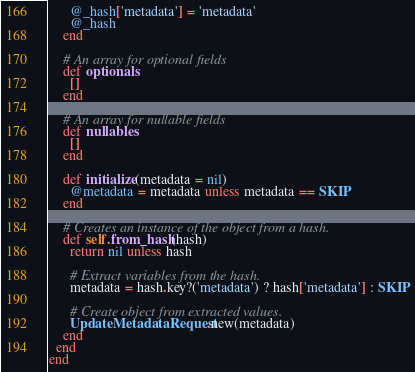Convert code to text. <code><loc_0><loc_0><loc_500><loc_500><_Ruby_>      @_hash['metadata'] = 'metadata'
      @_hash
    end

    # An array for optional fields
    def optionals
      []
    end

    # An array for nullable fields
    def nullables
      []
    end

    def initialize(metadata = nil)
      @metadata = metadata unless metadata == SKIP
    end

    # Creates an instance of the object from a hash.
    def self.from_hash(hash)
      return nil unless hash

      # Extract variables from the hash.
      metadata = hash.key?('metadata') ? hash['metadata'] : SKIP

      # Create object from extracted values.
      UpdateMetadataRequest.new(metadata)
    end
  end
end
</code> 